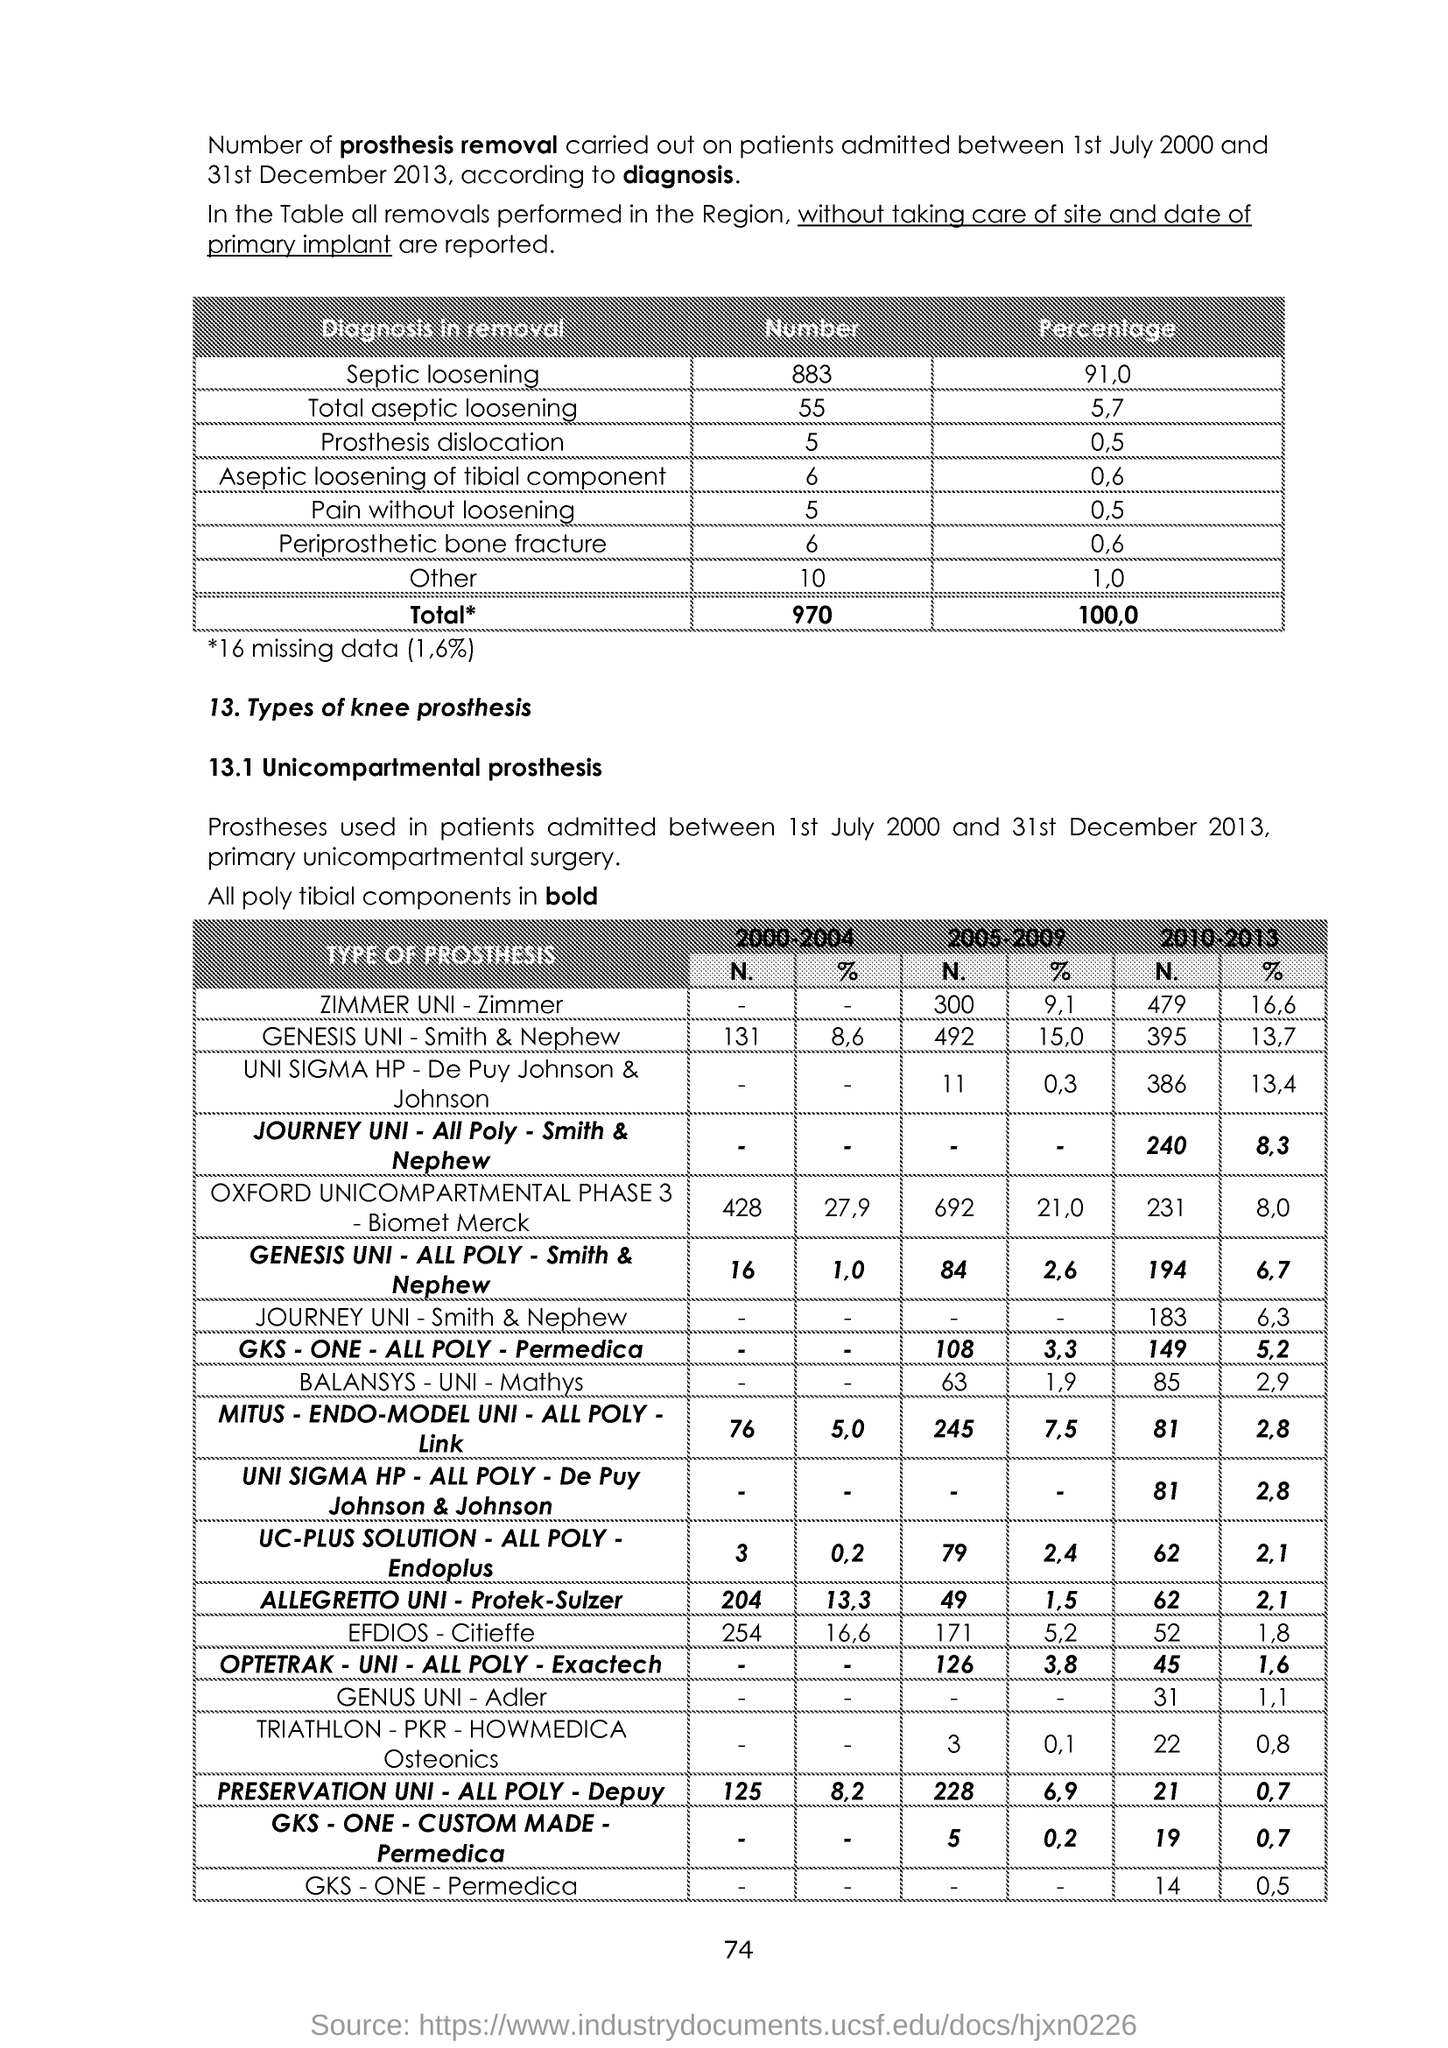What is the Page Number?
Keep it short and to the point. 74. 